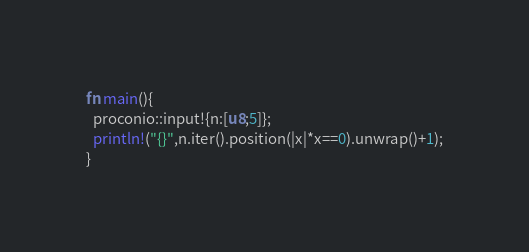Convert code to text. <code><loc_0><loc_0><loc_500><loc_500><_Rust_>fn main(){
  proconio::input!{n:[u8;5]};
  println!("{}",n.iter().position(|x|*x==0).unwrap()+1);
}</code> 